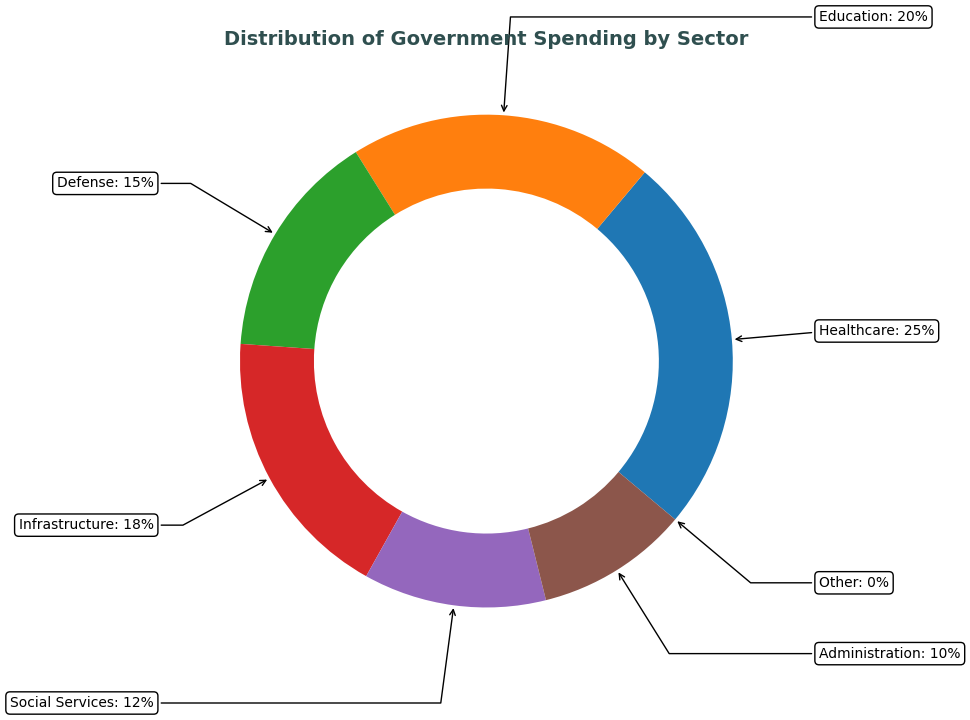What sector receives the largest portion of government spending? According to the figure, the healthcare sector has the largest wedge in the ring chart, indicating it receives the highest percentage of government spending.
Answer: Healthcare Which two sectors have the closest percentage of government spending? By observing the figure, we can see that the Infrastructure sector (18%) and Education sector (20%) have spending percentages that are closest to each other.
Answer: Infrastructure and Education How much more is spent on healthcare than defense? First, we see that Healthcare is allocated 25%, while Defense is allocated 15%. Subtracting these values: 25% - 15% = 10%.
Answer: 10% What is the combined percentage of spending on social services and administration? The figure shows Social Services receive 12% and Administration receives 10%. Adding these values gives us: 12% + 10% = 22%.
Answer: 22% Which sector has the lowest government spending, excluding sectors with 0% spending? From the figure, we see that Administration has 10%, which is the smallest percentage among those with non-zero spending.
Answer: Administration How does the spending on education compare to that on defense? Observing the figure shows that Education receives 20% while Defense receives 15%. Therefore, Education has a higher percentage by 5%.
Answer: Education is higher by 5% What fraction of the total spending is allocated to infrastructure and social services combined? Infrastructure gets 18% and Social Services get 12%. Adding these, we get 18% + 12% = 30%, which is 30/100 or 3/10 (simplified fraction).
Answer: 3/10 If the total budget is $1,000,000, how much money is allocated to healthcare and administration combined? Healthcare is 25% and Administration is 10%. The combined percentage is 25% + 10% = 35%. Calculating 35% of $1,000,000 gives us (35/100) * 1,000,000 = $350,000.
Answer: $350,000 